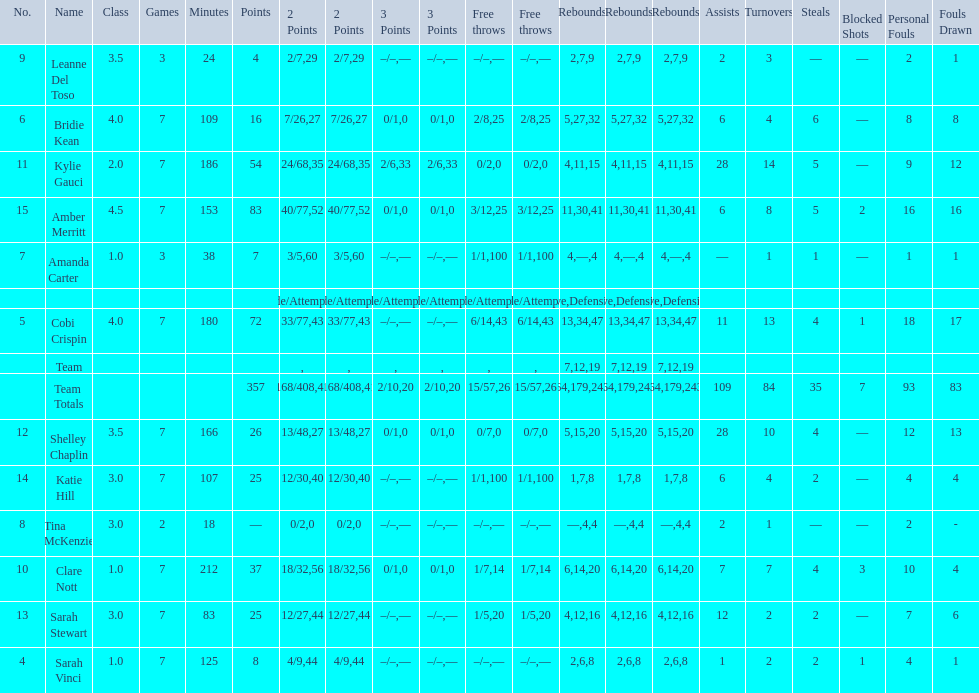Who is the last player on the list to not attempt a 3 point shot? Katie Hill. 